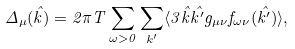<formula> <loc_0><loc_0><loc_500><loc_500>\Delta _ { \mu } ( \hat { k } ) = 2 \pi T \sum _ { \omega > 0 } \sum _ { k ^ { \prime } } \langle 3 \hat { k } \hat { k ^ { \prime } } g _ { \mu \nu } f _ { \omega \nu } ( \hat { k ^ { \prime } } ) \rangle ,</formula> 